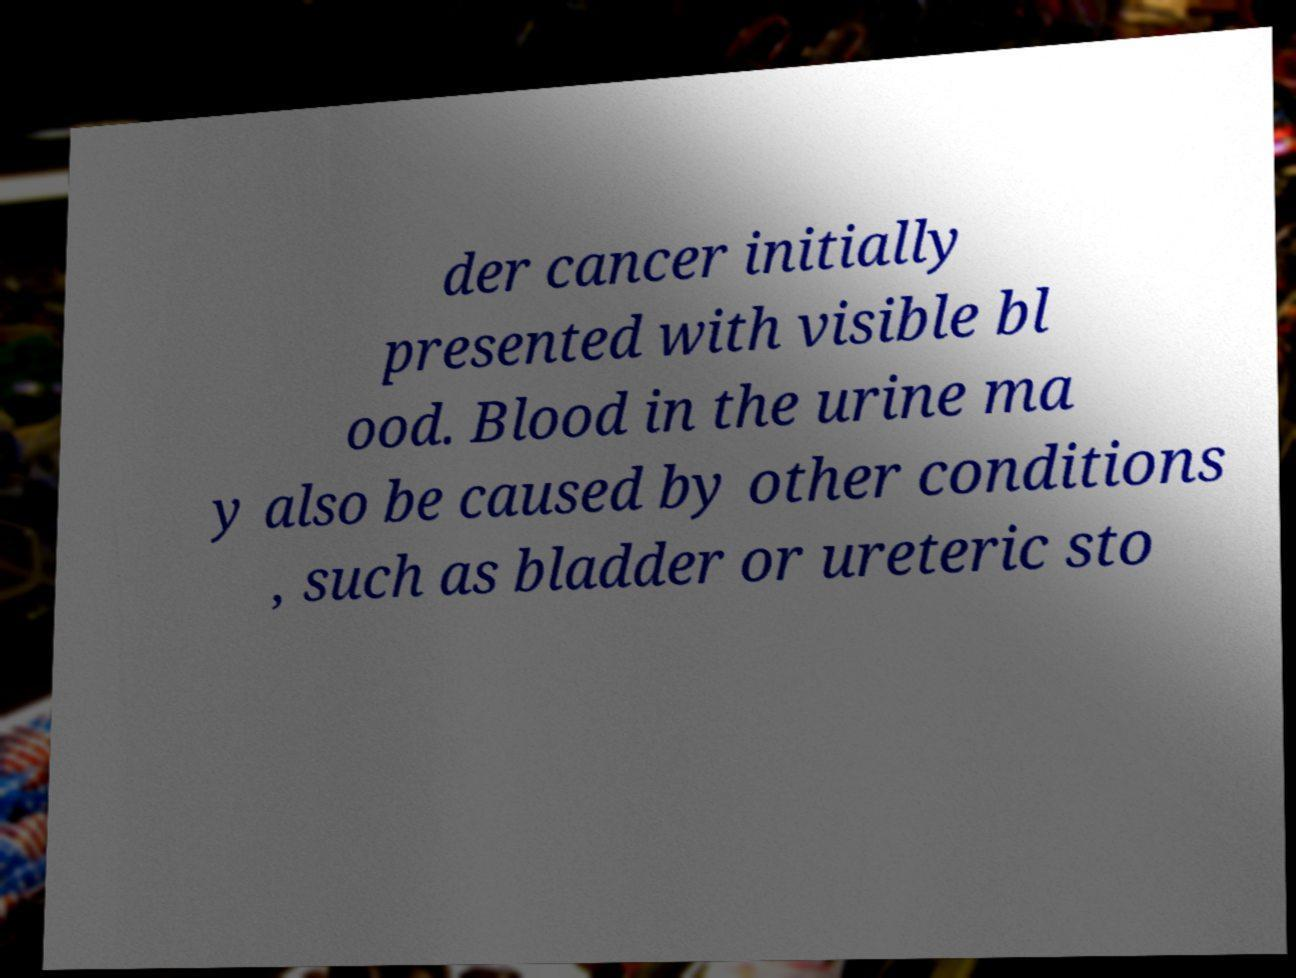What messages or text are displayed in this image? I need them in a readable, typed format. der cancer initially presented with visible bl ood. Blood in the urine ma y also be caused by other conditions , such as bladder or ureteric sto 